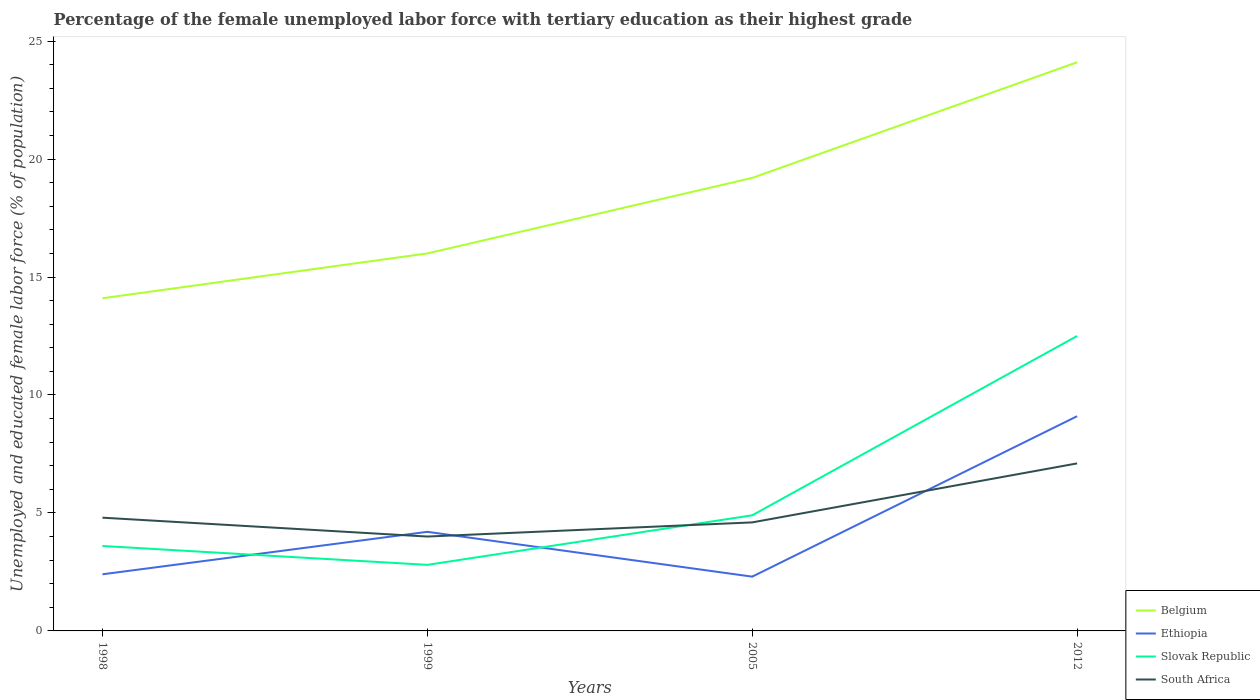Is the number of lines equal to the number of legend labels?
Your response must be concise. Yes. Across all years, what is the maximum percentage of the unemployed female labor force with tertiary education in Ethiopia?
Offer a terse response. 2.3. In which year was the percentage of the unemployed female labor force with tertiary education in Ethiopia maximum?
Provide a succinct answer. 2005. What is the total percentage of the unemployed female labor force with tertiary education in South Africa in the graph?
Keep it short and to the point. -2.3. What is the difference between the highest and the second highest percentage of the unemployed female labor force with tertiary education in South Africa?
Your answer should be very brief. 3.1. What is the difference between the highest and the lowest percentage of the unemployed female labor force with tertiary education in South Africa?
Keep it short and to the point. 1. Is the percentage of the unemployed female labor force with tertiary education in South Africa strictly greater than the percentage of the unemployed female labor force with tertiary education in Belgium over the years?
Your answer should be compact. Yes. Does the graph contain any zero values?
Your answer should be compact. No. How many legend labels are there?
Your response must be concise. 4. What is the title of the graph?
Make the answer very short. Percentage of the female unemployed labor force with tertiary education as their highest grade. What is the label or title of the X-axis?
Provide a short and direct response. Years. What is the label or title of the Y-axis?
Provide a short and direct response. Unemployed and educated female labor force (% of population). What is the Unemployed and educated female labor force (% of population) in Belgium in 1998?
Your answer should be compact. 14.1. What is the Unemployed and educated female labor force (% of population) in Ethiopia in 1998?
Your answer should be very brief. 2.4. What is the Unemployed and educated female labor force (% of population) in Slovak Republic in 1998?
Ensure brevity in your answer.  3.6. What is the Unemployed and educated female labor force (% of population) of South Africa in 1998?
Your answer should be very brief. 4.8. What is the Unemployed and educated female labor force (% of population) of Belgium in 1999?
Provide a short and direct response. 16. What is the Unemployed and educated female labor force (% of population) of Ethiopia in 1999?
Provide a short and direct response. 4.2. What is the Unemployed and educated female labor force (% of population) in Slovak Republic in 1999?
Offer a very short reply. 2.8. What is the Unemployed and educated female labor force (% of population) of South Africa in 1999?
Give a very brief answer. 4. What is the Unemployed and educated female labor force (% of population) of Belgium in 2005?
Offer a terse response. 19.2. What is the Unemployed and educated female labor force (% of population) in Ethiopia in 2005?
Offer a very short reply. 2.3. What is the Unemployed and educated female labor force (% of population) in Slovak Republic in 2005?
Provide a succinct answer. 4.9. What is the Unemployed and educated female labor force (% of population) in South Africa in 2005?
Give a very brief answer. 4.6. What is the Unemployed and educated female labor force (% of population) in Belgium in 2012?
Offer a very short reply. 24.1. What is the Unemployed and educated female labor force (% of population) of Ethiopia in 2012?
Ensure brevity in your answer.  9.1. What is the Unemployed and educated female labor force (% of population) in South Africa in 2012?
Provide a succinct answer. 7.1. Across all years, what is the maximum Unemployed and educated female labor force (% of population) of Belgium?
Your answer should be very brief. 24.1. Across all years, what is the maximum Unemployed and educated female labor force (% of population) of Ethiopia?
Provide a succinct answer. 9.1. Across all years, what is the maximum Unemployed and educated female labor force (% of population) of Slovak Republic?
Your answer should be very brief. 12.5. Across all years, what is the maximum Unemployed and educated female labor force (% of population) of South Africa?
Offer a very short reply. 7.1. Across all years, what is the minimum Unemployed and educated female labor force (% of population) in Belgium?
Keep it short and to the point. 14.1. Across all years, what is the minimum Unemployed and educated female labor force (% of population) in Ethiopia?
Your answer should be compact. 2.3. Across all years, what is the minimum Unemployed and educated female labor force (% of population) of Slovak Republic?
Your answer should be compact. 2.8. What is the total Unemployed and educated female labor force (% of population) of Belgium in the graph?
Your answer should be compact. 73.4. What is the total Unemployed and educated female labor force (% of population) of Ethiopia in the graph?
Provide a short and direct response. 18. What is the total Unemployed and educated female labor force (% of population) in Slovak Republic in the graph?
Offer a very short reply. 23.8. What is the difference between the Unemployed and educated female labor force (% of population) of South Africa in 1998 and that in 1999?
Keep it short and to the point. 0.8. What is the difference between the Unemployed and educated female labor force (% of population) of Belgium in 1998 and that in 2005?
Offer a very short reply. -5.1. What is the difference between the Unemployed and educated female labor force (% of population) of Slovak Republic in 1998 and that in 2005?
Your response must be concise. -1.3. What is the difference between the Unemployed and educated female labor force (% of population) of Belgium in 1998 and that in 2012?
Provide a succinct answer. -10. What is the difference between the Unemployed and educated female labor force (% of population) of Ethiopia in 1998 and that in 2012?
Your answer should be compact. -6.7. What is the difference between the Unemployed and educated female labor force (% of population) of South Africa in 1998 and that in 2012?
Provide a succinct answer. -2.3. What is the difference between the Unemployed and educated female labor force (% of population) in Belgium in 1999 and that in 2005?
Give a very brief answer. -3.2. What is the difference between the Unemployed and educated female labor force (% of population) of Slovak Republic in 1999 and that in 2005?
Ensure brevity in your answer.  -2.1. What is the difference between the Unemployed and educated female labor force (% of population) of Belgium in 1999 and that in 2012?
Ensure brevity in your answer.  -8.1. What is the difference between the Unemployed and educated female labor force (% of population) of Ethiopia in 1999 and that in 2012?
Make the answer very short. -4.9. What is the difference between the Unemployed and educated female labor force (% of population) in Belgium in 1998 and the Unemployed and educated female labor force (% of population) in Ethiopia in 1999?
Keep it short and to the point. 9.9. What is the difference between the Unemployed and educated female labor force (% of population) of Belgium in 1998 and the Unemployed and educated female labor force (% of population) of Slovak Republic in 1999?
Provide a succinct answer. 11.3. What is the difference between the Unemployed and educated female labor force (% of population) of Ethiopia in 1998 and the Unemployed and educated female labor force (% of population) of Slovak Republic in 1999?
Give a very brief answer. -0.4. What is the difference between the Unemployed and educated female labor force (% of population) of Belgium in 1998 and the Unemployed and educated female labor force (% of population) of Ethiopia in 2005?
Keep it short and to the point. 11.8. What is the difference between the Unemployed and educated female labor force (% of population) in Ethiopia in 1998 and the Unemployed and educated female labor force (% of population) in South Africa in 2005?
Make the answer very short. -2.2. What is the difference between the Unemployed and educated female labor force (% of population) of Slovak Republic in 1998 and the Unemployed and educated female labor force (% of population) of South Africa in 2005?
Offer a very short reply. -1. What is the difference between the Unemployed and educated female labor force (% of population) in Belgium in 1998 and the Unemployed and educated female labor force (% of population) in Slovak Republic in 2012?
Offer a terse response. 1.6. What is the difference between the Unemployed and educated female labor force (% of population) in Belgium in 1998 and the Unemployed and educated female labor force (% of population) in South Africa in 2012?
Ensure brevity in your answer.  7. What is the difference between the Unemployed and educated female labor force (% of population) in Ethiopia in 1998 and the Unemployed and educated female labor force (% of population) in South Africa in 2012?
Your response must be concise. -4.7. What is the difference between the Unemployed and educated female labor force (% of population) of Belgium in 1999 and the Unemployed and educated female labor force (% of population) of Ethiopia in 2005?
Your answer should be compact. 13.7. What is the difference between the Unemployed and educated female labor force (% of population) of Belgium in 1999 and the Unemployed and educated female labor force (% of population) of South Africa in 2005?
Your response must be concise. 11.4. What is the difference between the Unemployed and educated female labor force (% of population) of Belgium in 1999 and the Unemployed and educated female labor force (% of population) of Ethiopia in 2012?
Your answer should be very brief. 6.9. What is the difference between the Unemployed and educated female labor force (% of population) in Ethiopia in 1999 and the Unemployed and educated female labor force (% of population) in Slovak Republic in 2012?
Provide a short and direct response. -8.3. What is the difference between the Unemployed and educated female labor force (% of population) of Ethiopia in 1999 and the Unemployed and educated female labor force (% of population) of South Africa in 2012?
Keep it short and to the point. -2.9. What is the difference between the Unemployed and educated female labor force (% of population) of Belgium in 2005 and the Unemployed and educated female labor force (% of population) of Ethiopia in 2012?
Make the answer very short. 10.1. What is the difference between the Unemployed and educated female labor force (% of population) in Belgium in 2005 and the Unemployed and educated female labor force (% of population) in Slovak Republic in 2012?
Your answer should be compact. 6.7. What is the difference between the Unemployed and educated female labor force (% of population) of Belgium in 2005 and the Unemployed and educated female labor force (% of population) of South Africa in 2012?
Keep it short and to the point. 12.1. What is the difference between the Unemployed and educated female labor force (% of population) in Slovak Republic in 2005 and the Unemployed and educated female labor force (% of population) in South Africa in 2012?
Your response must be concise. -2.2. What is the average Unemployed and educated female labor force (% of population) of Belgium per year?
Give a very brief answer. 18.35. What is the average Unemployed and educated female labor force (% of population) of Ethiopia per year?
Offer a very short reply. 4.5. What is the average Unemployed and educated female labor force (% of population) in Slovak Republic per year?
Ensure brevity in your answer.  5.95. What is the average Unemployed and educated female labor force (% of population) of South Africa per year?
Offer a very short reply. 5.12. In the year 1998, what is the difference between the Unemployed and educated female labor force (% of population) in Belgium and Unemployed and educated female labor force (% of population) in Ethiopia?
Provide a succinct answer. 11.7. In the year 1998, what is the difference between the Unemployed and educated female labor force (% of population) of Belgium and Unemployed and educated female labor force (% of population) of South Africa?
Your answer should be compact. 9.3. In the year 1999, what is the difference between the Unemployed and educated female labor force (% of population) in Belgium and Unemployed and educated female labor force (% of population) in Slovak Republic?
Your answer should be very brief. 13.2. In the year 1999, what is the difference between the Unemployed and educated female labor force (% of population) of Belgium and Unemployed and educated female labor force (% of population) of South Africa?
Give a very brief answer. 12. In the year 1999, what is the difference between the Unemployed and educated female labor force (% of population) in Ethiopia and Unemployed and educated female labor force (% of population) in Slovak Republic?
Your answer should be compact. 1.4. In the year 1999, what is the difference between the Unemployed and educated female labor force (% of population) of Ethiopia and Unemployed and educated female labor force (% of population) of South Africa?
Ensure brevity in your answer.  0.2. In the year 2005, what is the difference between the Unemployed and educated female labor force (% of population) in Belgium and Unemployed and educated female labor force (% of population) in Slovak Republic?
Your response must be concise. 14.3. In the year 2005, what is the difference between the Unemployed and educated female labor force (% of population) in Ethiopia and Unemployed and educated female labor force (% of population) in Slovak Republic?
Provide a short and direct response. -2.6. In the year 2005, what is the difference between the Unemployed and educated female labor force (% of population) of Slovak Republic and Unemployed and educated female labor force (% of population) of South Africa?
Make the answer very short. 0.3. In the year 2012, what is the difference between the Unemployed and educated female labor force (% of population) of Belgium and Unemployed and educated female labor force (% of population) of Ethiopia?
Offer a very short reply. 15. In the year 2012, what is the difference between the Unemployed and educated female labor force (% of population) of Belgium and Unemployed and educated female labor force (% of population) of South Africa?
Your response must be concise. 17. In the year 2012, what is the difference between the Unemployed and educated female labor force (% of population) in Slovak Republic and Unemployed and educated female labor force (% of population) in South Africa?
Your response must be concise. 5.4. What is the ratio of the Unemployed and educated female labor force (% of population) in Belgium in 1998 to that in 1999?
Provide a succinct answer. 0.88. What is the ratio of the Unemployed and educated female labor force (% of population) of Slovak Republic in 1998 to that in 1999?
Ensure brevity in your answer.  1.29. What is the ratio of the Unemployed and educated female labor force (% of population) in Belgium in 1998 to that in 2005?
Make the answer very short. 0.73. What is the ratio of the Unemployed and educated female labor force (% of population) in Ethiopia in 1998 to that in 2005?
Give a very brief answer. 1.04. What is the ratio of the Unemployed and educated female labor force (% of population) of Slovak Republic in 1998 to that in 2005?
Your response must be concise. 0.73. What is the ratio of the Unemployed and educated female labor force (% of population) in South Africa in 1998 to that in 2005?
Your answer should be compact. 1.04. What is the ratio of the Unemployed and educated female labor force (% of population) of Belgium in 1998 to that in 2012?
Provide a succinct answer. 0.59. What is the ratio of the Unemployed and educated female labor force (% of population) of Ethiopia in 1998 to that in 2012?
Provide a short and direct response. 0.26. What is the ratio of the Unemployed and educated female labor force (% of population) of Slovak Republic in 1998 to that in 2012?
Provide a short and direct response. 0.29. What is the ratio of the Unemployed and educated female labor force (% of population) of South Africa in 1998 to that in 2012?
Make the answer very short. 0.68. What is the ratio of the Unemployed and educated female labor force (% of population) in Belgium in 1999 to that in 2005?
Make the answer very short. 0.83. What is the ratio of the Unemployed and educated female labor force (% of population) of Ethiopia in 1999 to that in 2005?
Give a very brief answer. 1.83. What is the ratio of the Unemployed and educated female labor force (% of population) of South Africa in 1999 to that in 2005?
Provide a succinct answer. 0.87. What is the ratio of the Unemployed and educated female labor force (% of population) in Belgium in 1999 to that in 2012?
Offer a terse response. 0.66. What is the ratio of the Unemployed and educated female labor force (% of population) in Ethiopia in 1999 to that in 2012?
Provide a short and direct response. 0.46. What is the ratio of the Unemployed and educated female labor force (% of population) of Slovak Republic in 1999 to that in 2012?
Provide a succinct answer. 0.22. What is the ratio of the Unemployed and educated female labor force (% of population) of South Africa in 1999 to that in 2012?
Keep it short and to the point. 0.56. What is the ratio of the Unemployed and educated female labor force (% of population) in Belgium in 2005 to that in 2012?
Make the answer very short. 0.8. What is the ratio of the Unemployed and educated female labor force (% of population) of Ethiopia in 2005 to that in 2012?
Your answer should be very brief. 0.25. What is the ratio of the Unemployed and educated female labor force (% of population) of Slovak Republic in 2005 to that in 2012?
Provide a short and direct response. 0.39. What is the ratio of the Unemployed and educated female labor force (% of population) of South Africa in 2005 to that in 2012?
Give a very brief answer. 0.65. What is the difference between the highest and the second highest Unemployed and educated female labor force (% of population) in Belgium?
Your answer should be very brief. 4.9. What is the difference between the highest and the second highest Unemployed and educated female labor force (% of population) of Ethiopia?
Give a very brief answer. 4.9. What is the difference between the highest and the second highest Unemployed and educated female labor force (% of population) in Slovak Republic?
Your answer should be compact. 7.6. What is the difference between the highest and the second highest Unemployed and educated female labor force (% of population) of South Africa?
Keep it short and to the point. 2.3. What is the difference between the highest and the lowest Unemployed and educated female labor force (% of population) of Ethiopia?
Ensure brevity in your answer.  6.8. 